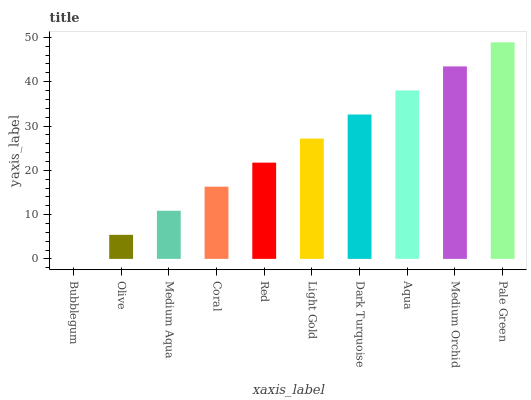Is Bubblegum the minimum?
Answer yes or no. Yes. Is Pale Green the maximum?
Answer yes or no. Yes. Is Olive the minimum?
Answer yes or no. No. Is Olive the maximum?
Answer yes or no. No. Is Olive greater than Bubblegum?
Answer yes or no. Yes. Is Bubblegum less than Olive?
Answer yes or no. Yes. Is Bubblegum greater than Olive?
Answer yes or no. No. Is Olive less than Bubblegum?
Answer yes or no. No. Is Light Gold the high median?
Answer yes or no. Yes. Is Red the low median?
Answer yes or no. Yes. Is Bubblegum the high median?
Answer yes or no. No. Is Bubblegum the low median?
Answer yes or no. No. 